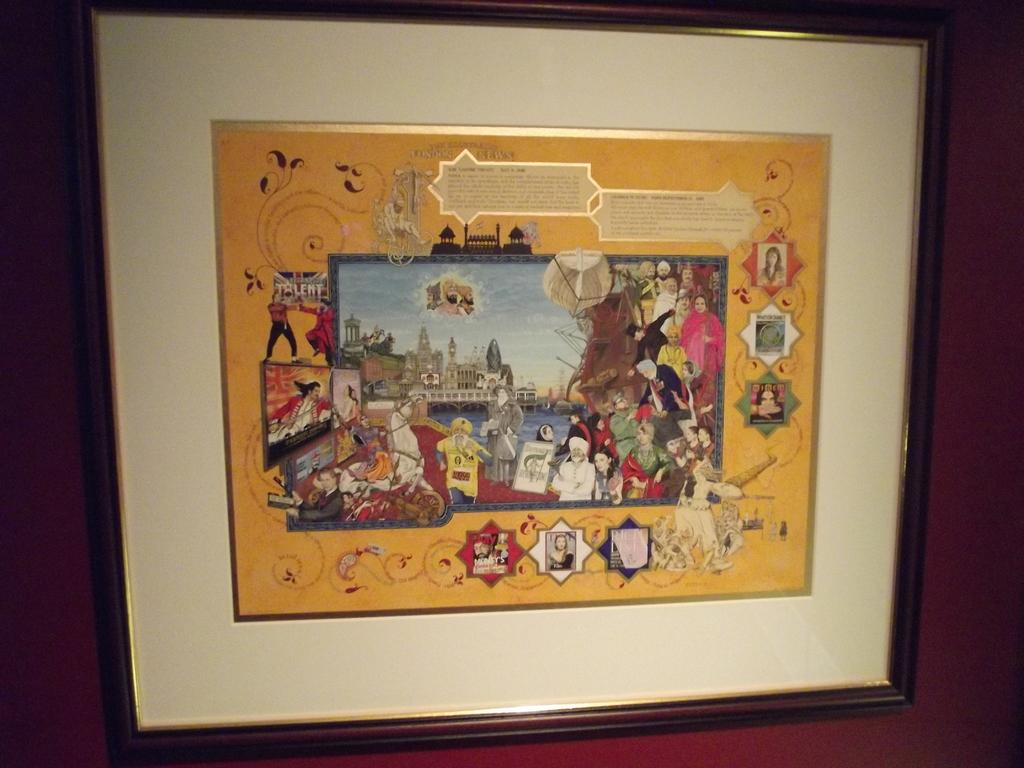What is present in the image that typically holds a photograph? There is a photo frame in the image. Can you describe the location of the photo frame in the image? The photo frame is on an object. What type of bear can be seen interacting with the photo frame in the image? There is no bear present in the image; it only features a photo frame on an object. 